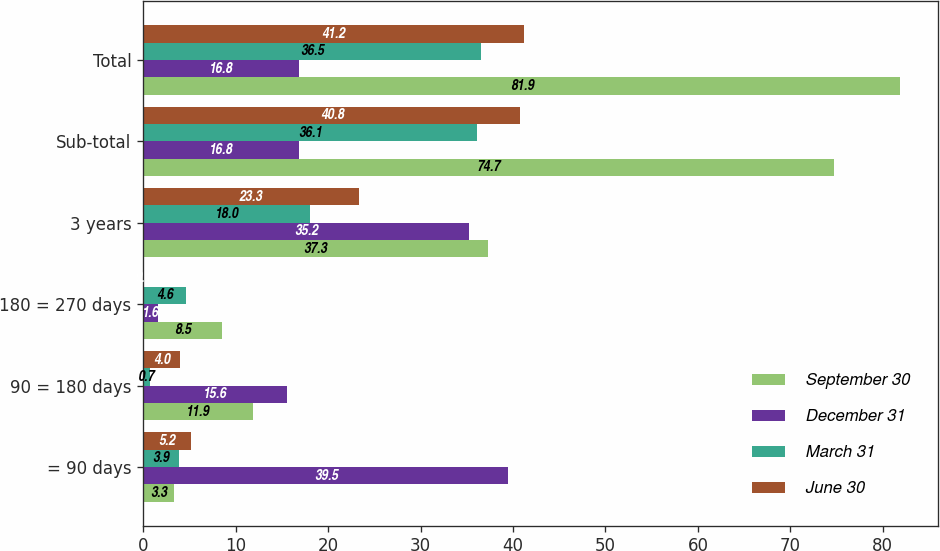<chart> <loc_0><loc_0><loc_500><loc_500><stacked_bar_chart><ecel><fcel>= 90 days<fcel>90 = 180 days<fcel>180 = 270 days<fcel>3 years<fcel>Sub-total<fcel>Total<nl><fcel>September 30<fcel>3.3<fcel>11.9<fcel>8.5<fcel>37.3<fcel>74.7<fcel>81.9<nl><fcel>December 31<fcel>39.5<fcel>15.6<fcel>1.6<fcel>35.2<fcel>16.8<fcel>16.8<nl><fcel>March 31<fcel>3.9<fcel>0.7<fcel>4.6<fcel>18<fcel>36.1<fcel>36.5<nl><fcel>June 30<fcel>5.2<fcel>4<fcel>0.1<fcel>23.3<fcel>40.8<fcel>41.2<nl></chart> 